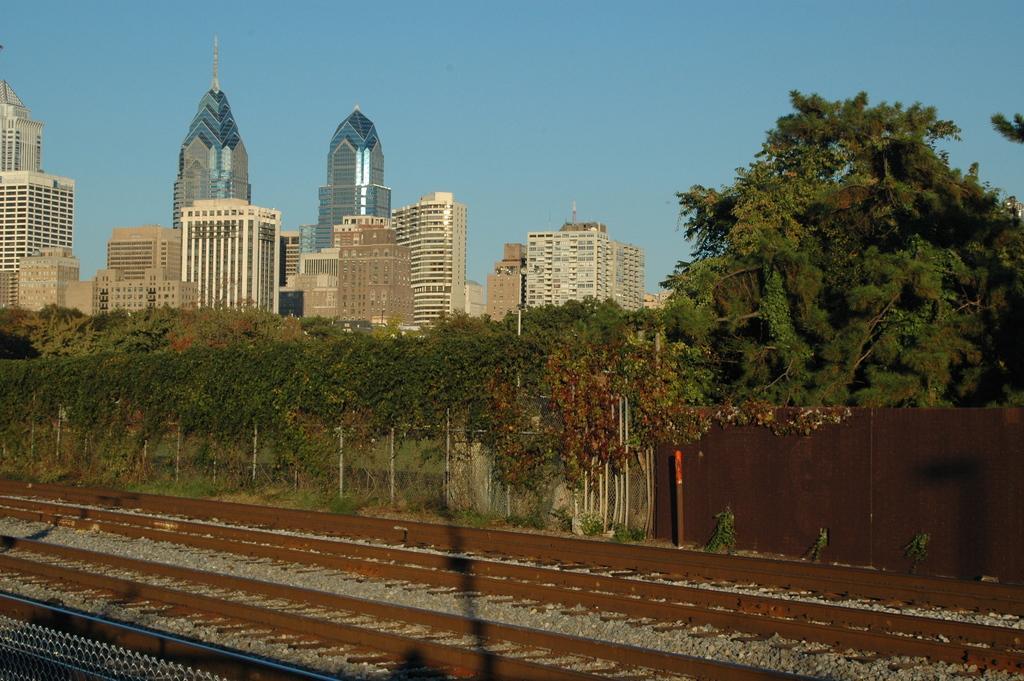Describe this image in one or two sentences. At the bottom of the image I can see the railway tracks and stones on the ground. In the background there is fencing at back of it I can see many trees and buildings. At the top of the image I can see the sky. 